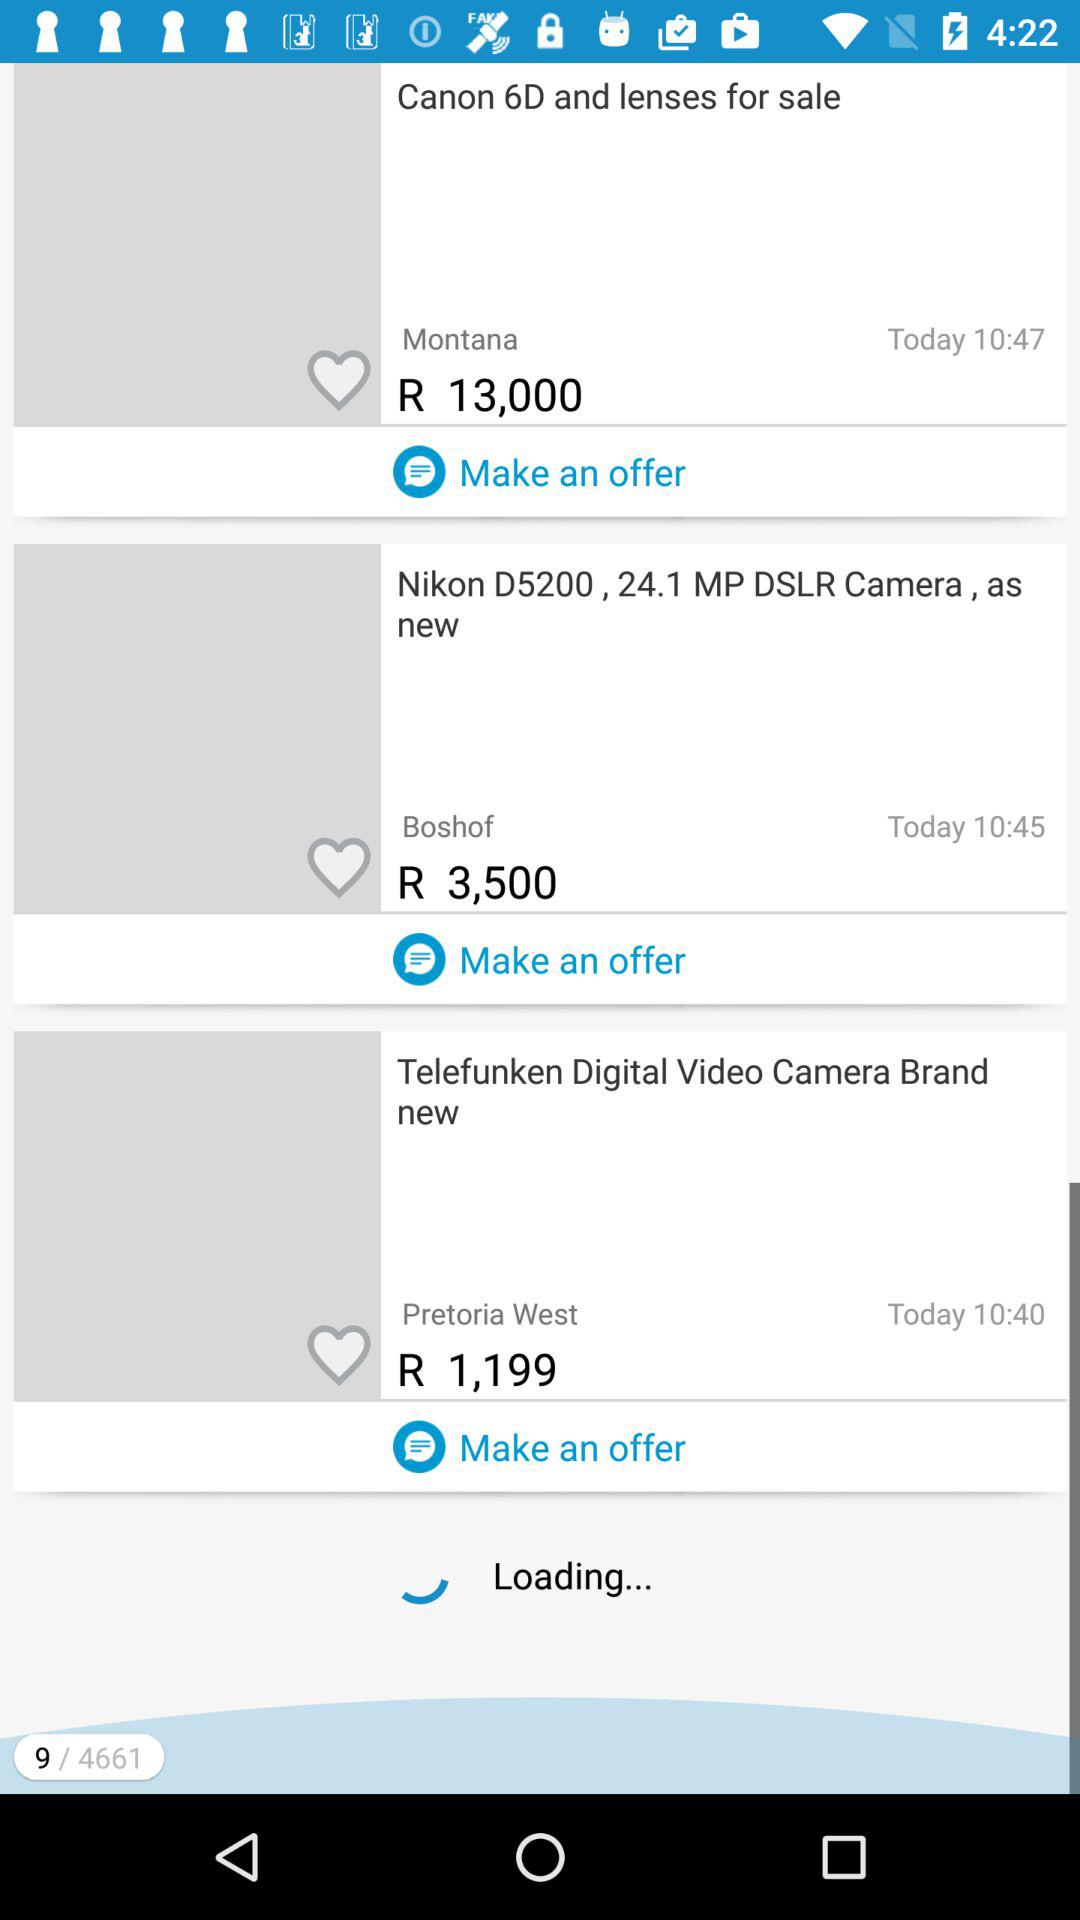How much is the cheapest item?
Answer the question using a single word or phrase. R 1,199 